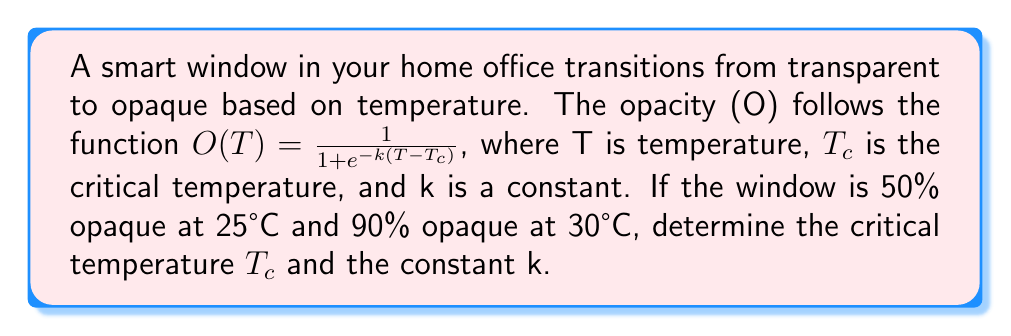Provide a solution to this math problem. 1) The opacity function is a logistic function, with $T_c$ being the temperature at which the window is 50% opaque.

2) At 50% opacity (O = 0.5), T = $T_c$. So we know that $T_c$ = 25°C.

3) Now we can use the 90% opacity point to find k:

   $0.9 = \frac{1}{1 + e^{-k(30-25)}}$

4) Solving for k:
   $\frac{1}{0.9} = 1 + e^{-5k}$
   $\frac{1}{9} = e^{-5k}$
   $\ln(\frac{1}{9}) = -5k$
   $k = \frac{\ln(9)}{5} \approx 0.44$

5) We can verify this by plugging these values back into the original equation:

   $O(T) = \frac{1}{1 + e^{-0.44(T-25)}}$

   This gives us 0.5 at T=25°C and approximately 0.9 at T=30°C.
Answer: $T_c = 25°C, k \approx 0.44$ 